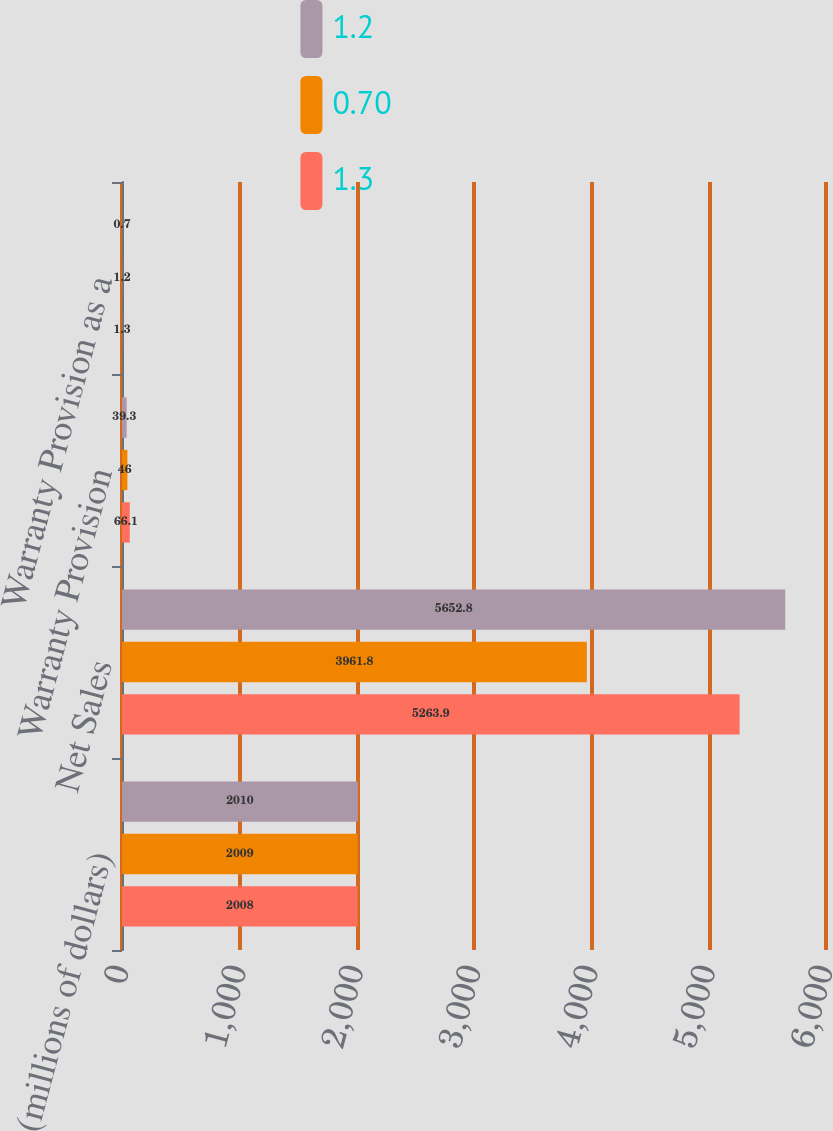<chart> <loc_0><loc_0><loc_500><loc_500><stacked_bar_chart><ecel><fcel>(millions of dollars)<fcel>Net Sales<fcel>Warranty Provision<fcel>Warranty Provision as a<nl><fcel>1.2<fcel>2010<fcel>5652.8<fcel>39.3<fcel>0.7<nl><fcel>0.7<fcel>2009<fcel>3961.8<fcel>46<fcel>1.2<nl><fcel>1.3<fcel>2008<fcel>5263.9<fcel>66.1<fcel>1.3<nl></chart> 